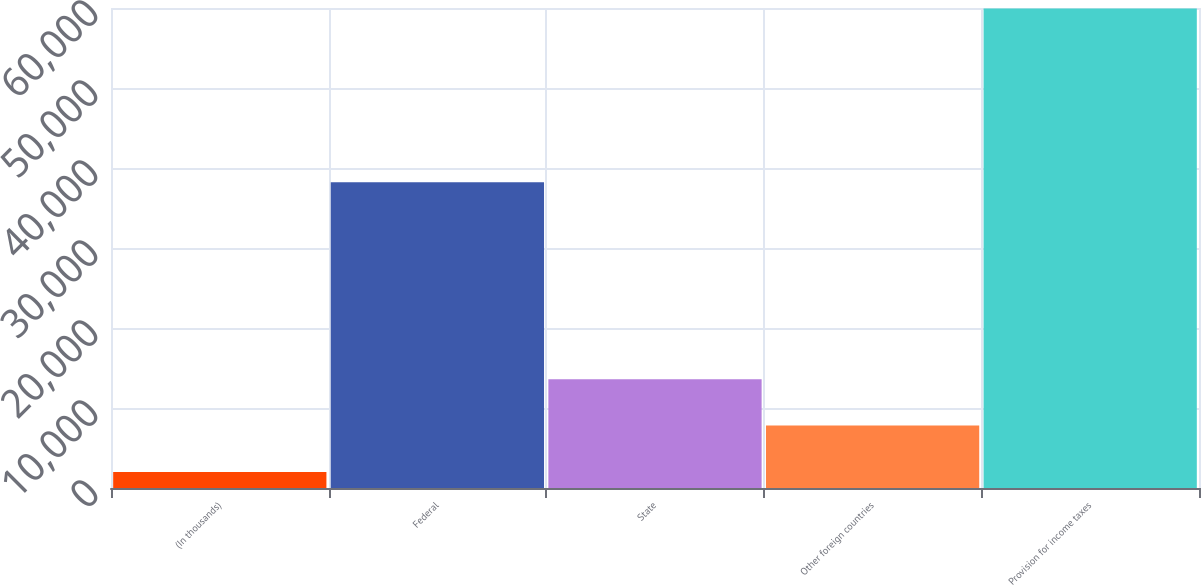Convert chart to OTSL. <chart><loc_0><loc_0><loc_500><loc_500><bar_chart><fcel>(In thousands)<fcel>Federal<fcel>State<fcel>Other foreign countries<fcel>Provision for income taxes<nl><fcel>2011<fcel>38209<fcel>13597.4<fcel>7804.2<fcel>59943<nl></chart> 